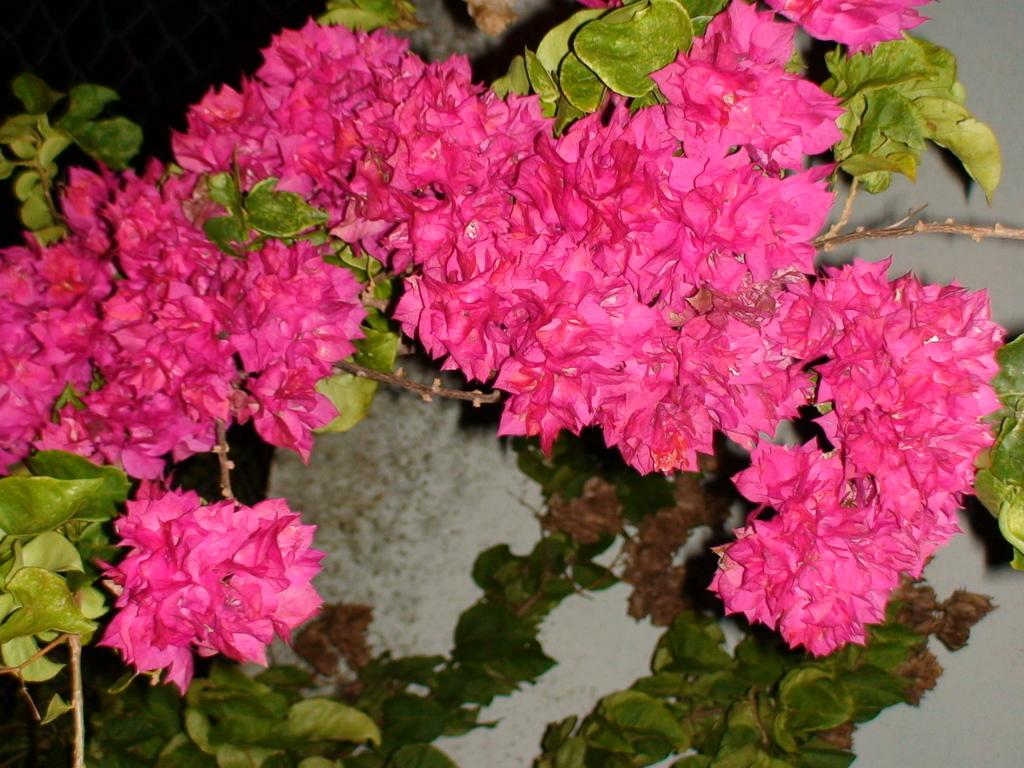Where was the image taken? The image is taken outdoors. What can be seen in the image besides the outdoor setting? There is a plant in the image. What is special about the plant? The plant has flowers. What color are the flowers on the plant? The flowers are pink in color. How many sisters are visible in the image? There are no sisters present in the image; it features a plant with pink flowers. What type of ball is being used to play with the plant in the image? There is no ball present in the image; it features a plant with pink flowers. 